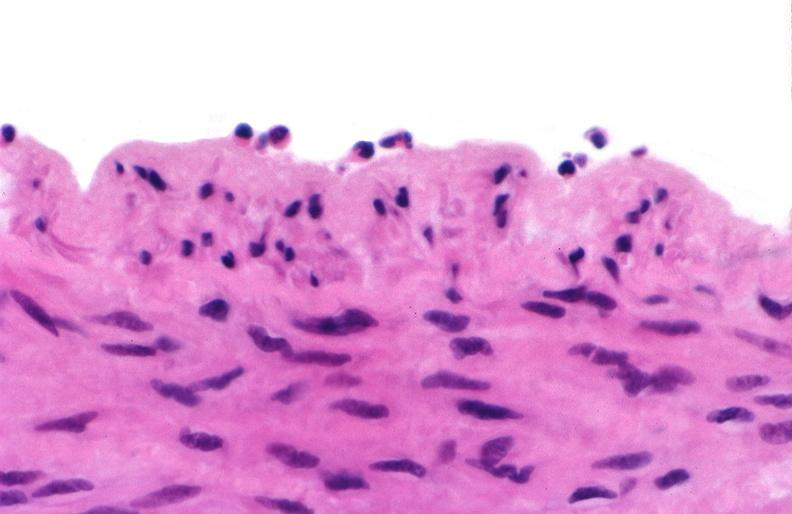does all the fat necrosis show acute inflammation, rolling leukocytes polymorphonuclear neutrophils?
Answer the question using a single word or phrase. No 